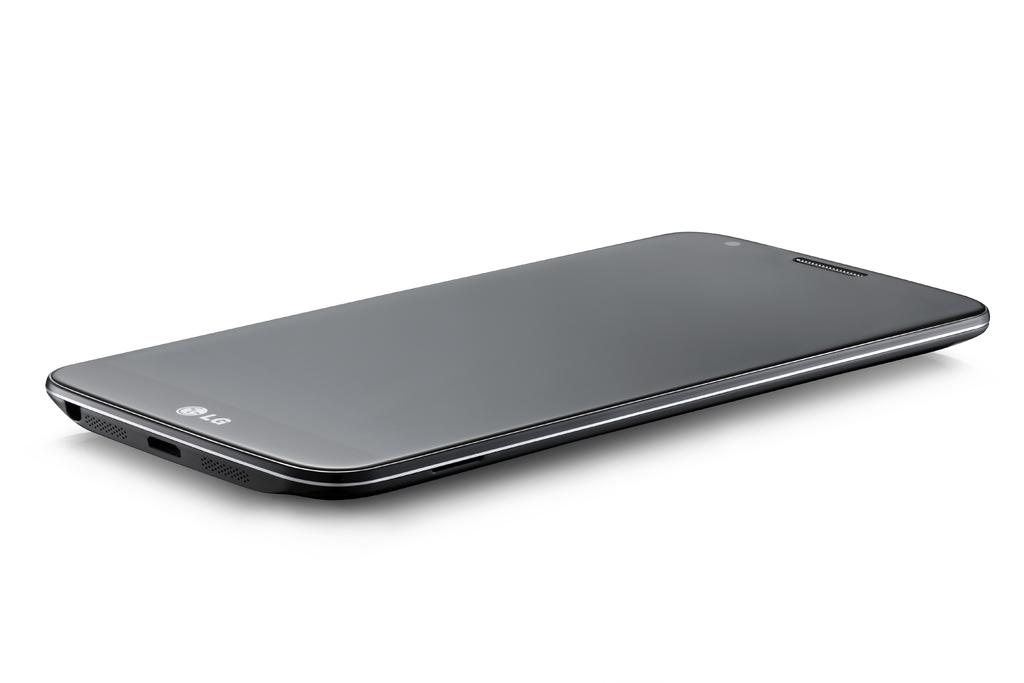<image>
Summarize the visual content of the image. a sleek display of an LG Cell phone 